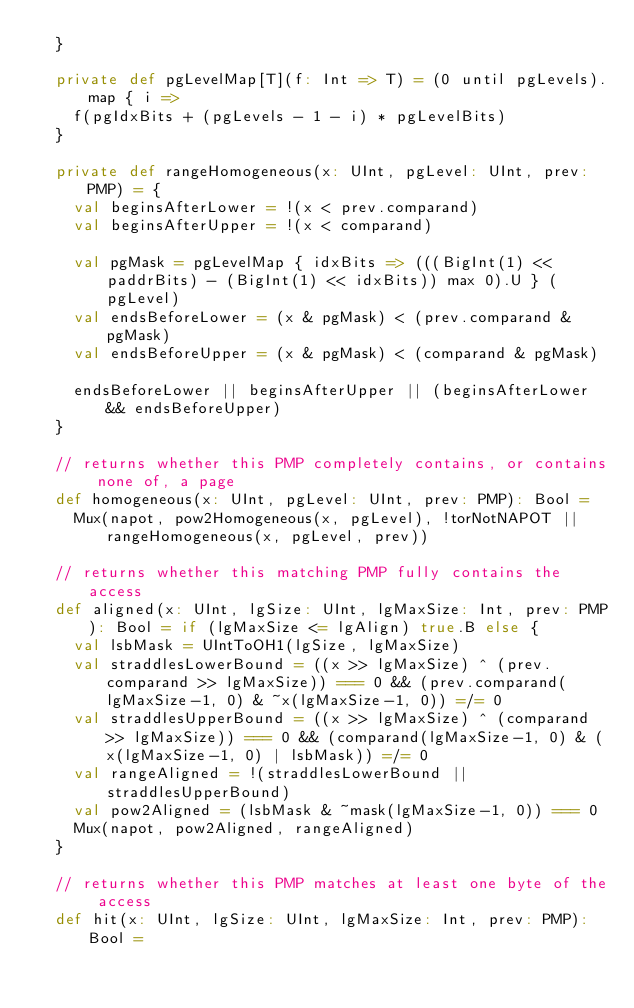Convert code to text. <code><loc_0><loc_0><loc_500><loc_500><_Scala_>  }

  private def pgLevelMap[T](f: Int => T) = (0 until pgLevels).map { i =>
    f(pgIdxBits + (pgLevels - 1 - i) * pgLevelBits)
  }

  private def rangeHomogeneous(x: UInt, pgLevel: UInt, prev: PMP) = {
    val beginsAfterLower = !(x < prev.comparand)
    val beginsAfterUpper = !(x < comparand)

    val pgMask = pgLevelMap { idxBits => (((BigInt(1) << paddrBits) - (BigInt(1) << idxBits)) max 0).U } (pgLevel)
    val endsBeforeLower = (x & pgMask) < (prev.comparand & pgMask)
    val endsBeforeUpper = (x & pgMask) < (comparand & pgMask)

    endsBeforeLower || beginsAfterUpper || (beginsAfterLower && endsBeforeUpper)
  }

  // returns whether this PMP completely contains, or contains none of, a page
  def homogeneous(x: UInt, pgLevel: UInt, prev: PMP): Bool =
    Mux(napot, pow2Homogeneous(x, pgLevel), !torNotNAPOT || rangeHomogeneous(x, pgLevel, prev))

  // returns whether this matching PMP fully contains the access
  def aligned(x: UInt, lgSize: UInt, lgMaxSize: Int, prev: PMP): Bool = if (lgMaxSize <= lgAlign) true.B else {
    val lsbMask = UIntToOH1(lgSize, lgMaxSize)
    val straddlesLowerBound = ((x >> lgMaxSize) ^ (prev.comparand >> lgMaxSize)) === 0 && (prev.comparand(lgMaxSize-1, 0) & ~x(lgMaxSize-1, 0)) =/= 0
    val straddlesUpperBound = ((x >> lgMaxSize) ^ (comparand >> lgMaxSize)) === 0 && (comparand(lgMaxSize-1, 0) & (x(lgMaxSize-1, 0) | lsbMask)) =/= 0
    val rangeAligned = !(straddlesLowerBound || straddlesUpperBound)
    val pow2Aligned = (lsbMask & ~mask(lgMaxSize-1, 0)) === 0
    Mux(napot, pow2Aligned, rangeAligned)
  }

  // returns whether this PMP matches at least one byte of the access
  def hit(x: UInt, lgSize: UInt, lgMaxSize: Int, prev: PMP): Bool =</code> 